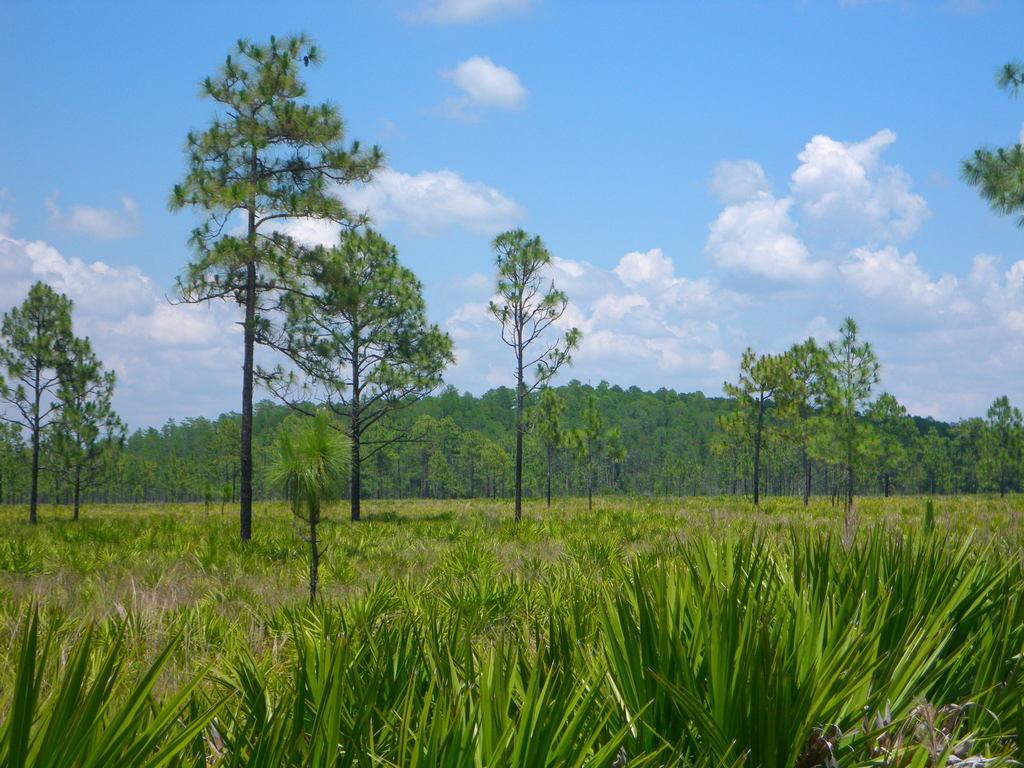How would you summarize this image in a sentence or two? As we can see in the image there is grass and trees. On the top there is sky and clouds. 